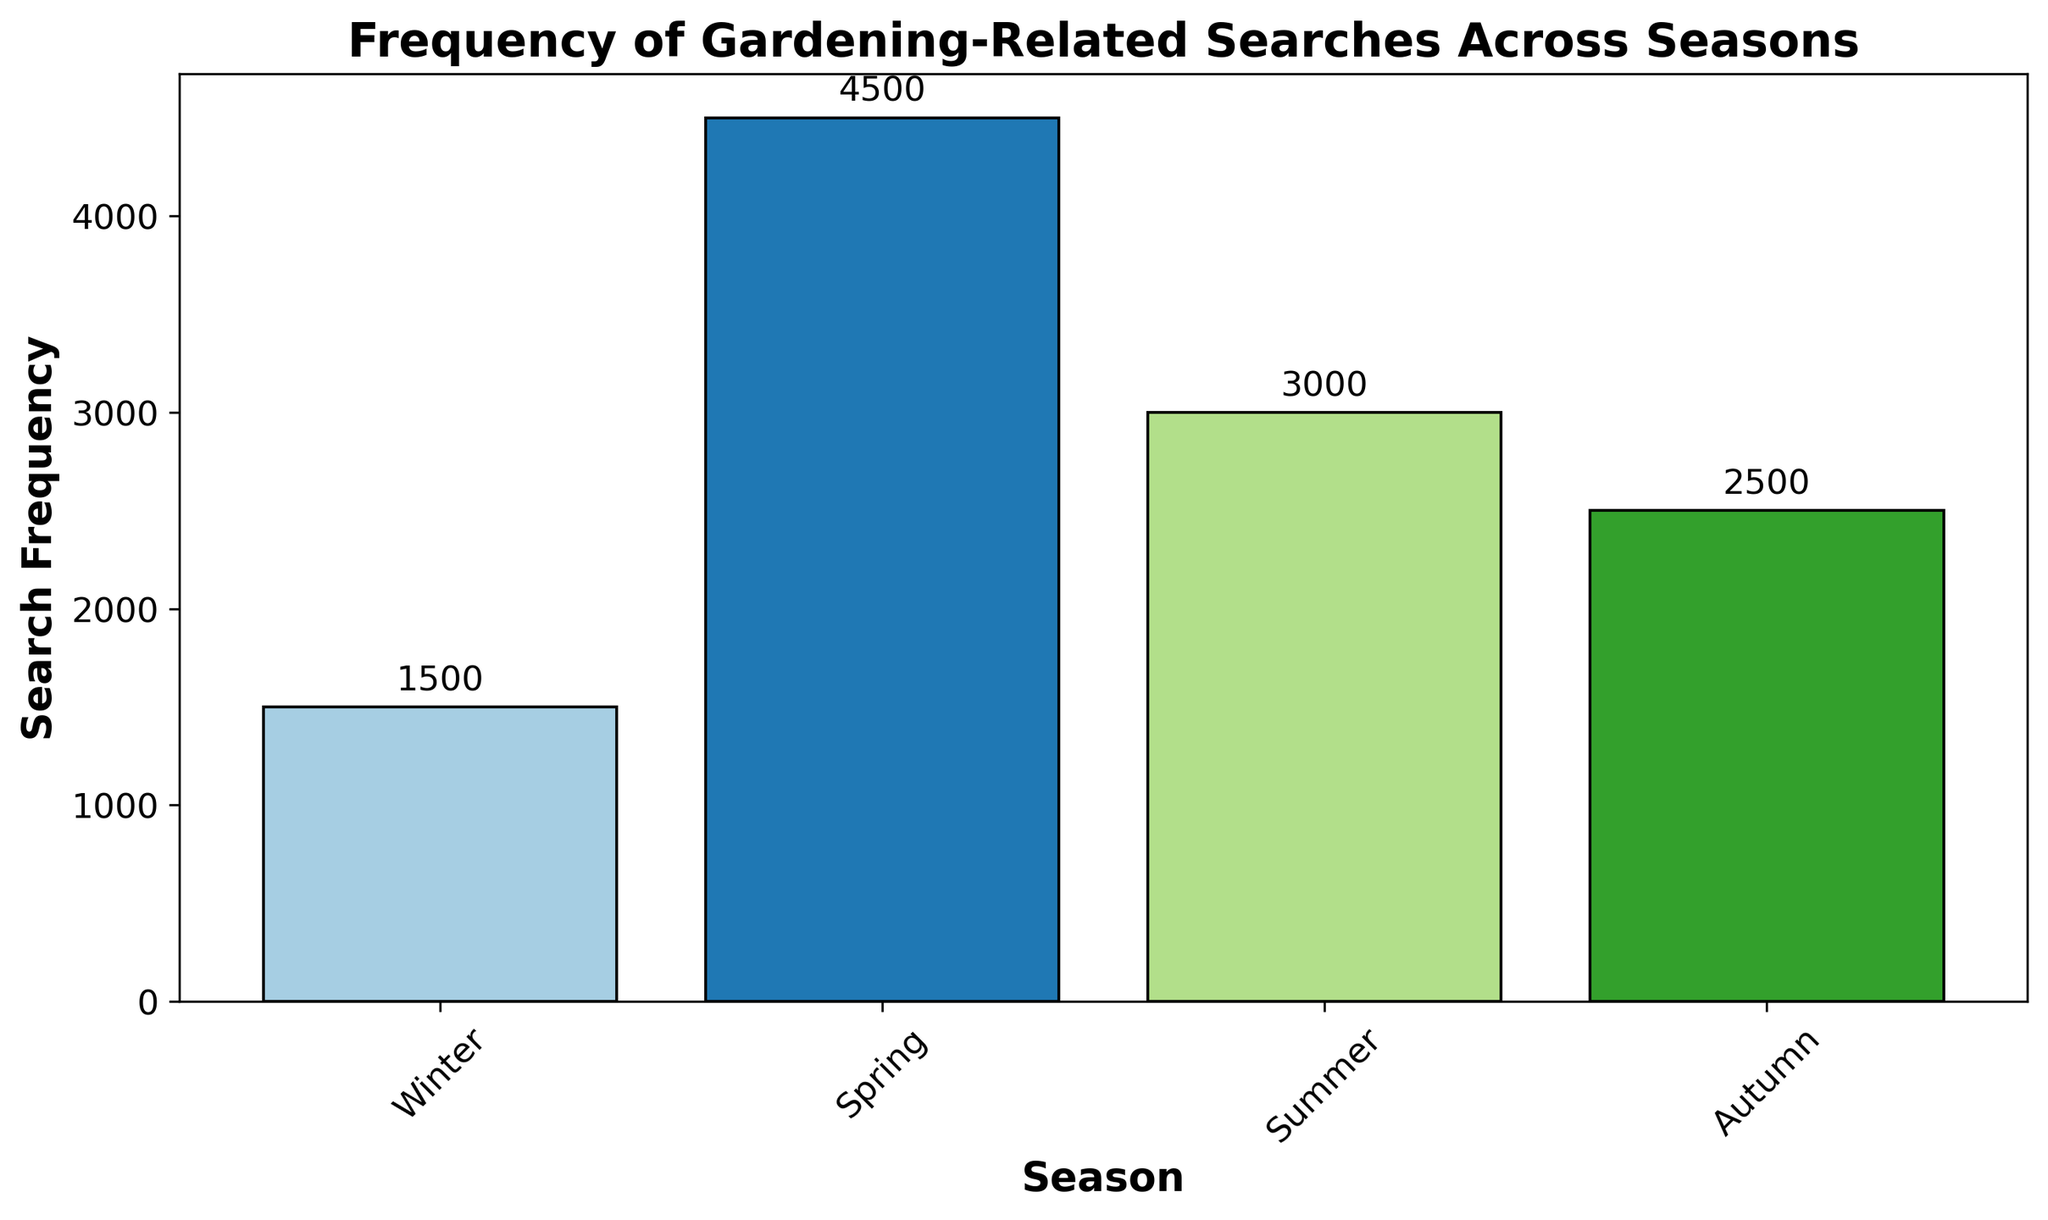What season has the highest frequency of gardening-related searches? Look at the bar chart and identify the bar with the greatest height. The tallest bar is aligned with spring, indicating the highest frequency.
Answer: Spring Which season has the lowest frequency of gardening-related searches? Identify the bar with the shortest height in the bar chart. The winter bar is the shortest, indicating it has the lowest frequency.
Answer: Winter What is the difference in search frequency between spring and winter? Refer to the height of the bars for spring and winter. Spring has a height of 4500 and winter has a height of 1500. The difference is calculated as 4500 - 1500.
Answer: 3000 How does the search frequency in summer compare to that in autumn? Compare the heights of the summer and autumn bars. Summer has a height of 3000, which is higher than autumn's height of 2500.
Answer: Summer is higher Which season shows a search frequency closest to 3000? Check the height of each bar and find the one closest to 3000. The summer season has a frequency exactly at 3000.
Answer: Summer What is the average search frequency across all seasons? Sum the search frequencies for all seasons (1500 + 4500 + 3000 + 2500) and divide by the number of seasons (4). Calculation: (1500 + 4500 + 3000 + 2500) / 4 = 11500 / 4.
Answer: 2875 What are the colors of the bars representing spring and autumn? Look at the colors of the bars in the chart. Spring is represented by a dark blue bar, and autumn is represented by a green bar.
Answer: Spring is dark blue, Autumn is green If we combine the search frequencies of winter and autumn, which season's frequency would that be closest to? Combine winter (1500) and autumn (2500) frequencies to get 4000, then compare it with other seasons' frequencies. Closest to spring (4500).
Answer: Spring What is the sum of the search frequencies for summer and autumn? Add the search frequencies for summer (3000) and autumn (2500). Calculation: 3000 + 2500.
Answer: 5500 